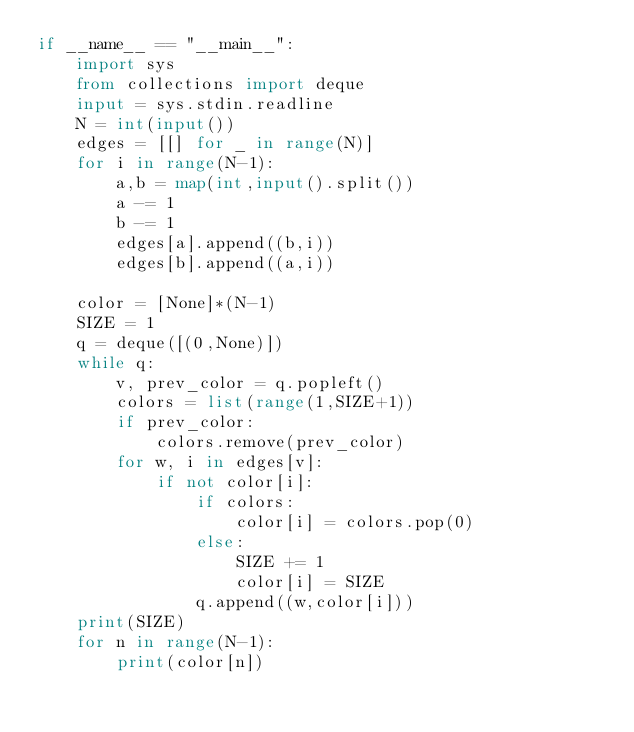Convert code to text. <code><loc_0><loc_0><loc_500><loc_500><_Python_>if __name__ == "__main__":
    import sys
    from collections import deque
    input = sys.stdin.readline
    N = int(input())
    edges = [[] for _ in range(N)]
    for i in range(N-1):
        a,b = map(int,input().split())
        a -= 1
        b -= 1
        edges[a].append((b,i))
        edges[b].append((a,i))

    color = [None]*(N-1)
    SIZE = 1
    q = deque([(0,None)])
    while q:
        v, prev_color = q.popleft()
        colors = list(range(1,SIZE+1))
        if prev_color:
            colors.remove(prev_color)
        for w, i in edges[v]:
            if not color[i]:
                if colors:
                    color[i] = colors.pop(0)
                else:
                    SIZE += 1
                    color[i] = SIZE
                q.append((w,color[i]))
    print(SIZE)
    for n in range(N-1):
        print(color[n])</code> 